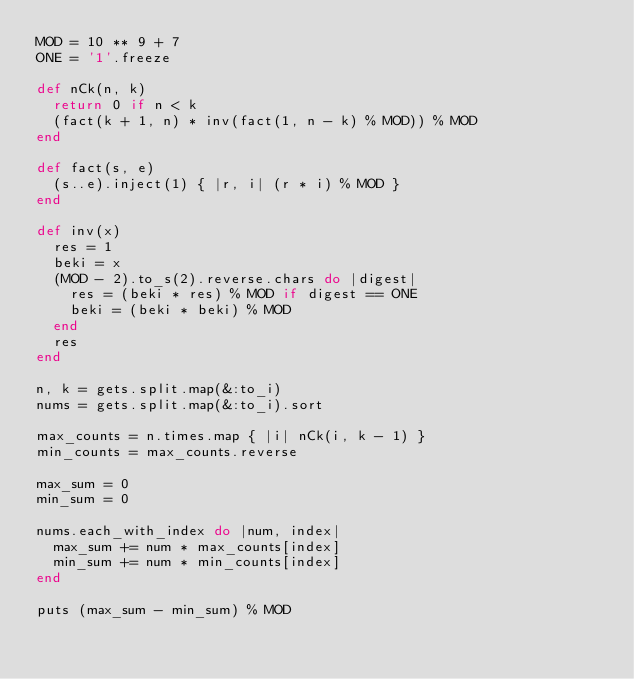<code> <loc_0><loc_0><loc_500><loc_500><_Ruby_>MOD = 10 ** 9 + 7
ONE = '1'.freeze

def nCk(n, k)
  return 0 if n < k
  (fact(k + 1, n) * inv(fact(1, n - k) % MOD)) % MOD
end

def fact(s, e)
  (s..e).inject(1) { |r, i| (r * i) % MOD }
end

def inv(x)
  res = 1
  beki = x
  (MOD - 2).to_s(2).reverse.chars do |digest|
    res = (beki * res) % MOD if digest == ONE
    beki = (beki * beki) % MOD
  end
  res
end

n, k = gets.split.map(&:to_i)
nums = gets.split.map(&:to_i).sort

max_counts = n.times.map { |i| nCk(i, k - 1) }
min_counts = max_counts.reverse

max_sum = 0
min_sum = 0

nums.each_with_index do |num, index|
  max_sum += num * max_counts[index]
  min_sum += num * min_counts[index]
end

puts (max_sum - min_sum) % MOD
</code> 